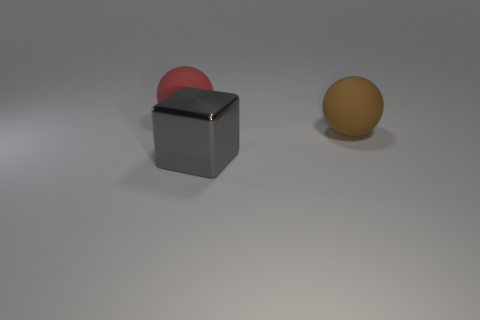Are there more gray cubes than gray matte spheres? Indeed, there are more gray cubes than gray matte spheres in the image. Specifically, there is one gray cube and no gray matte spheres present. 